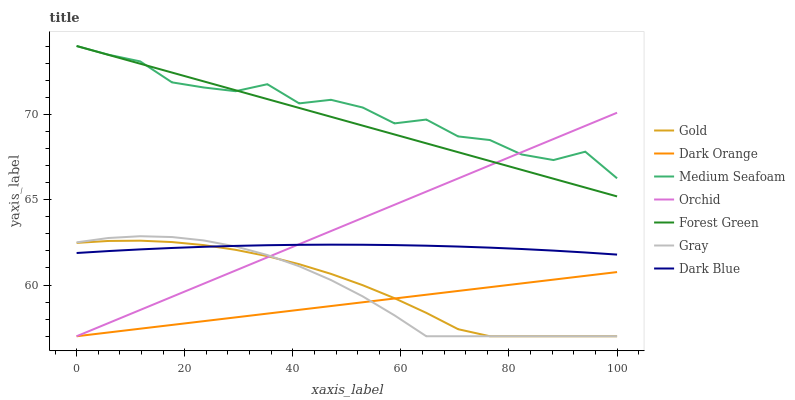Does Dark Orange have the minimum area under the curve?
Answer yes or no. Yes. Does Medium Seafoam have the maximum area under the curve?
Answer yes or no. Yes. Does Gold have the minimum area under the curve?
Answer yes or no. No. Does Gold have the maximum area under the curve?
Answer yes or no. No. Is Forest Green the smoothest?
Answer yes or no. Yes. Is Medium Seafoam the roughest?
Answer yes or no. Yes. Is Gold the smoothest?
Answer yes or no. No. Is Gold the roughest?
Answer yes or no. No. Does Dark Orange have the lowest value?
Answer yes or no. Yes. Does Dark Blue have the lowest value?
Answer yes or no. No. Does Medium Seafoam have the highest value?
Answer yes or no. Yes. Does Gold have the highest value?
Answer yes or no. No. Is Dark Orange less than Dark Blue?
Answer yes or no. Yes. Is Forest Green greater than Dark Orange?
Answer yes or no. Yes. Does Orchid intersect Medium Seafoam?
Answer yes or no. Yes. Is Orchid less than Medium Seafoam?
Answer yes or no. No. Is Orchid greater than Medium Seafoam?
Answer yes or no. No. Does Dark Orange intersect Dark Blue?
Answer yes or no. No. 